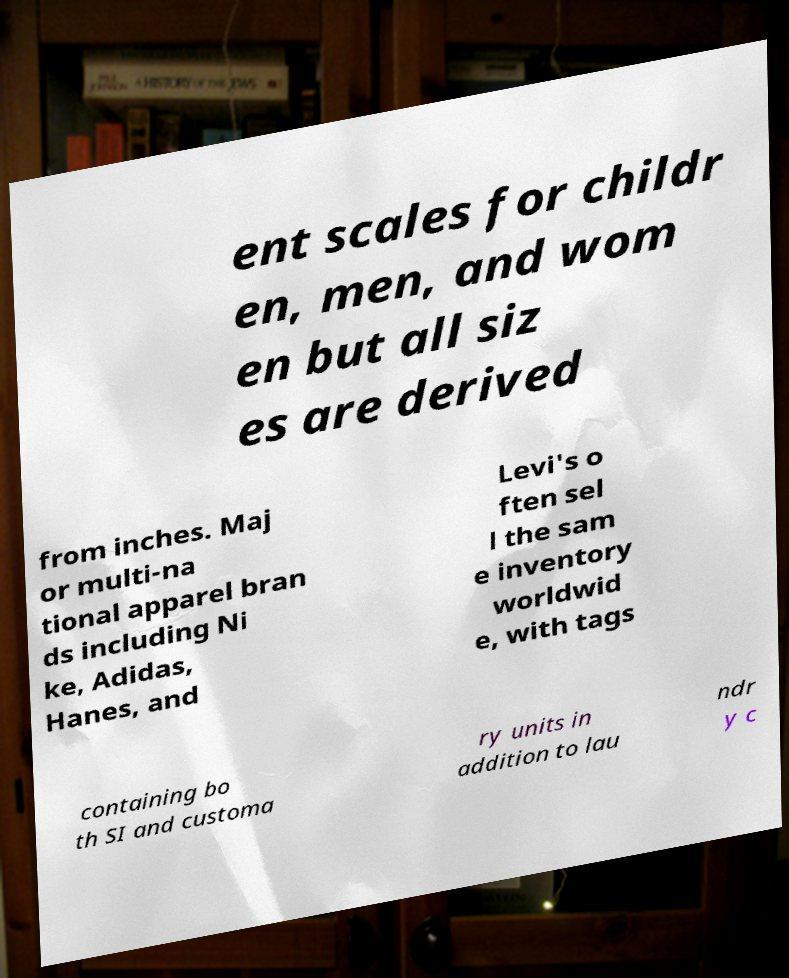I need the written content from this picture converted into text. Can you do that? ent scales for childr en, men, and wom en but all siz es are derived from inches. Maj or multi-na tional apparel bran ds including Ni ke, Adidas, Hanes, and Levi's o ften sel l the sam e inventory worldwid e, with tags containing bo th SI and customa ry units in addition to lau ndr y c 